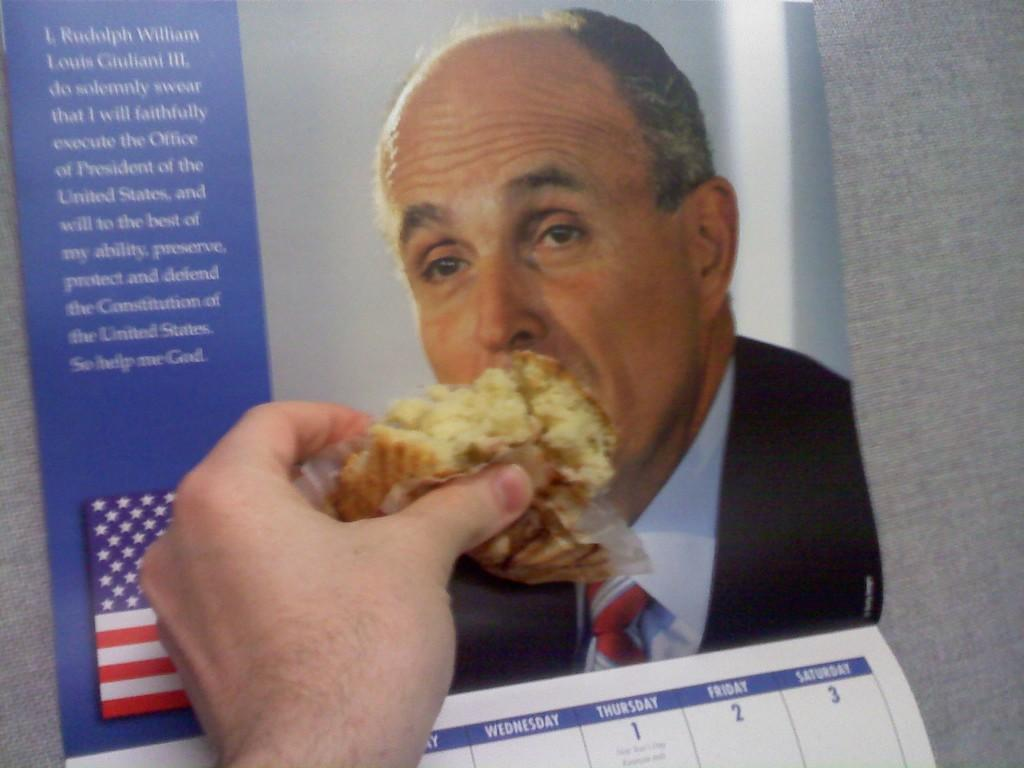<image>
Present a compact description of the photo's key features. Person putting a muffin to the mouth L. Rudolph William on a calendar. 